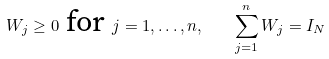Convert formula to latex. <formula><loc_0><loc_0><loc_500><loc_500>W _ { j } \geq 0 \text { for } j = 1 , \dots , n , \quad \sum _ { j = 1 } ^ { n } W _ { j } = I _ { N }</formula> 